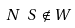Convert formula to latex. <formula><loc_0><loc_0><loc_500><loc_500>N \ S \notin W</formula> 